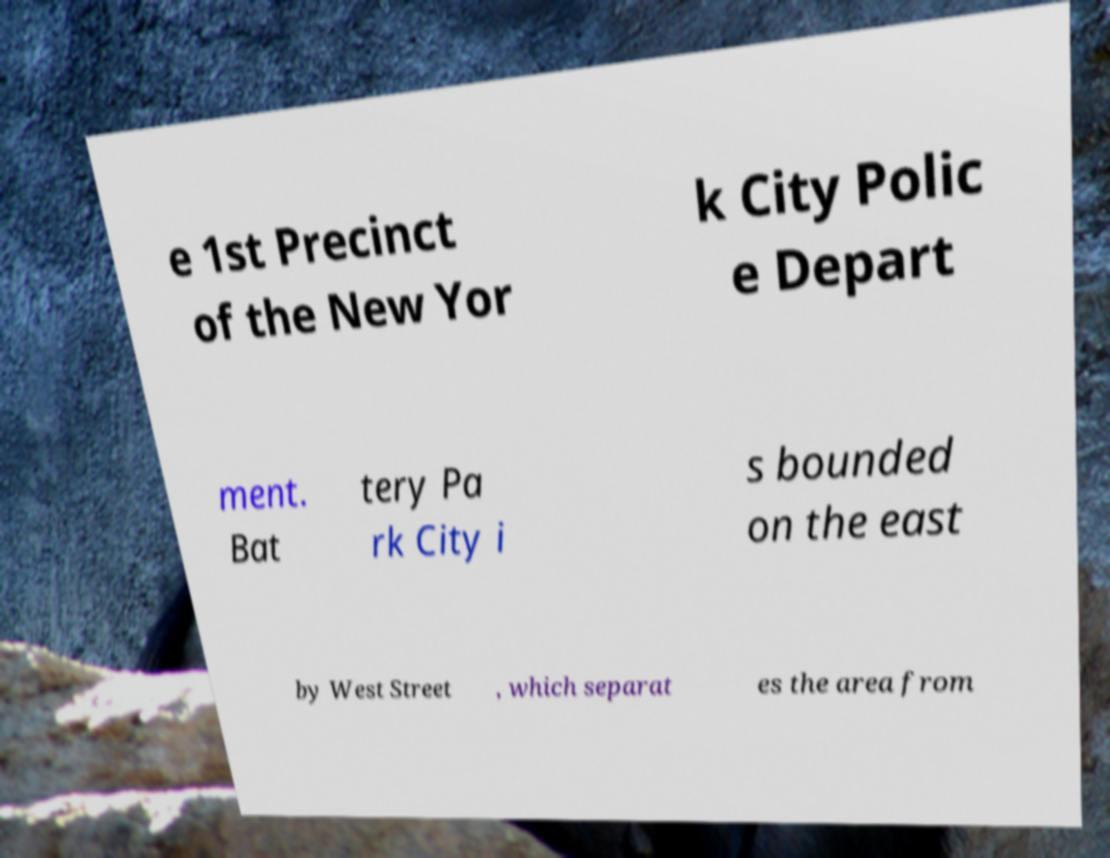Could you assist in decoding the text presented in this image and type it out clearly? e 1st Precinct of the New Yor k City Polic e Depart ment. Bat tery Pa rk City i s bounded on the east by West Street , which separat es the area from 